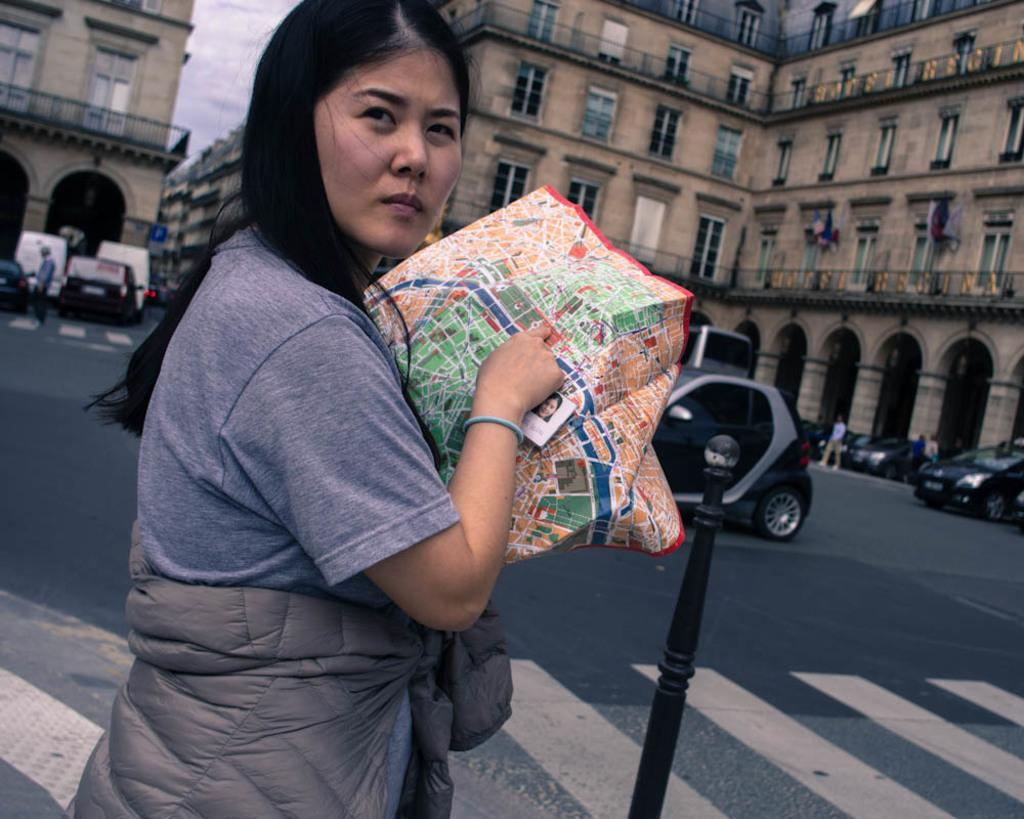What is the woman in the image doing? The woman is standing in the image and holding a bag. What is in front of the woman? There is a pole in front of the woman. What can be seen in the background of the image? Buildings, vehicles, people, and the sky are visible in the background of the image. What type of kettle is being used by the manager in the image? There is no manager or kettle present in the image. How many cows are visible in the image? There are no cows visible in the image. 